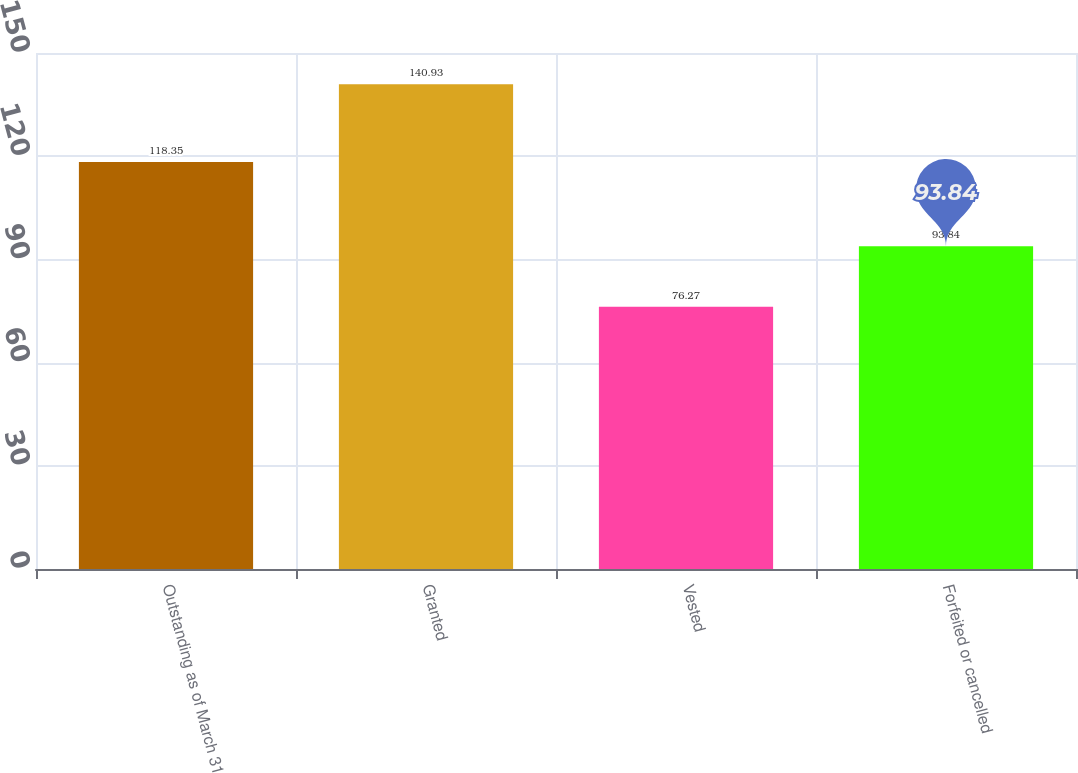<chart> <loc_0><loc_0><loc_500><loc_500><bar_chart><fcel>Outstanding as of March 31<fcel>Granted<fcel>Vested<fcel>Forfeited or cancelled<nl><fcel>118.35<fcel>140.93<fcel>76.27<fcel>93.84<nl></chart> 